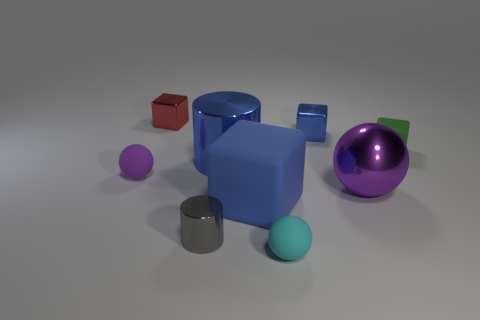What material is the object that is the same color as the large sphere?
Provide a succinct answer. Rubber. Is the large purple object made of the same material as the tiny purple ball?
Your response must be concise. No. What color is the tiny rubber sphere that is in front of the big blue object on the right side of the large metal thing to the left of the cyan ball?
Offer a terse response. Cyan. What is the shape of the small blue metal object?
Offer a very short reply. Cube. Does the big metal cylinder have the same color as the small metallic block on the right side of the small cyan sphere?
Keep it short and to the point. Yes. Is the number of tiny red things that are to the right of the purple metal thing the same as the number of rubber cubes?
Give a very brief answer. No. How many cyan things have the same size as the purple metal ball?
Offer a very short reply. 0. There is a big object that is the same color as the large block; what shape is it?
Provide a short and direct response. Cylinder. Is there a big metal sphere?
Ensure brevity in your answer.  Yes. There is a big metallic object in front of the blue metallic cylinder; is it the same shape as the metallic thing left of the small cylinder?
Keep it short and to the point. No. 